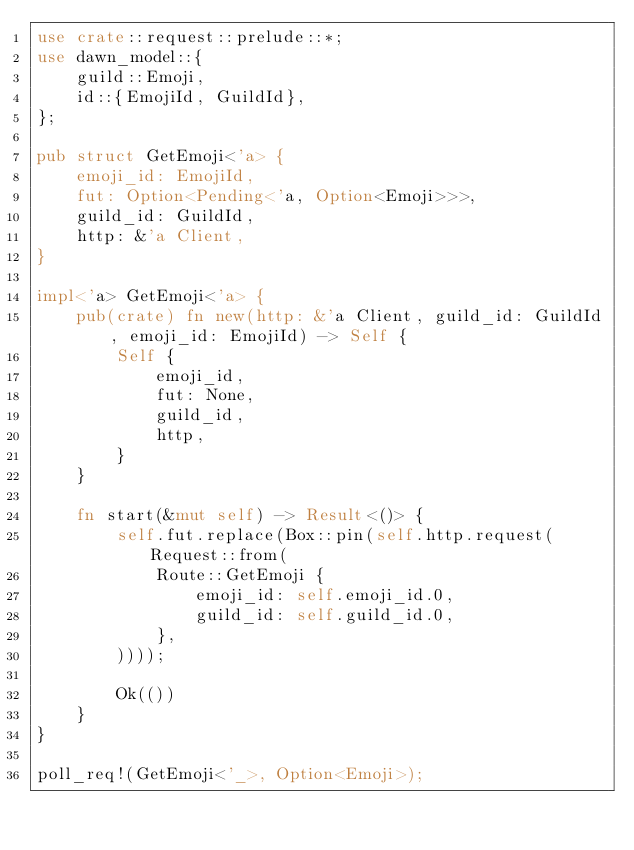Convert code to text. <code><loc_0><loc_0><loc_500><loc_500><_Rust_>use crate::request::prelude::*;
use dawn_model::{
    guild::Emoji,
    id::{EmojiId, GuildId},
};

pub struct GetEmoji<'a> {
    emoji_id: EmojiId,
    fut: Option<Pending<'a, Option<Emoji>>>,
    guild_id: GuildId,
    http: &'a Client,
}

impl<'a> GetEmoji<'a> {
    pub(crate) fn new(http: &'a Client, guild_id: GuildId, emoji_id: EmojiId) -> Self {
        Self {
            emoji_id,
            fut: None,
            guild_id,
            http,
        }
    }

    fn start(&mut self) -> Result<()> {
        self.fut.replace(Box::pin(self.http.request(Request::from(
            Route::GetEmoji {
                emoji_id: self.emoji_id.0,
                guild_id: self.guild_id.0,
            },
        ))));

        Ok(())
    }
}

poll_req!(GetEmoji<'_>, Option<Emoji>);
</code> 